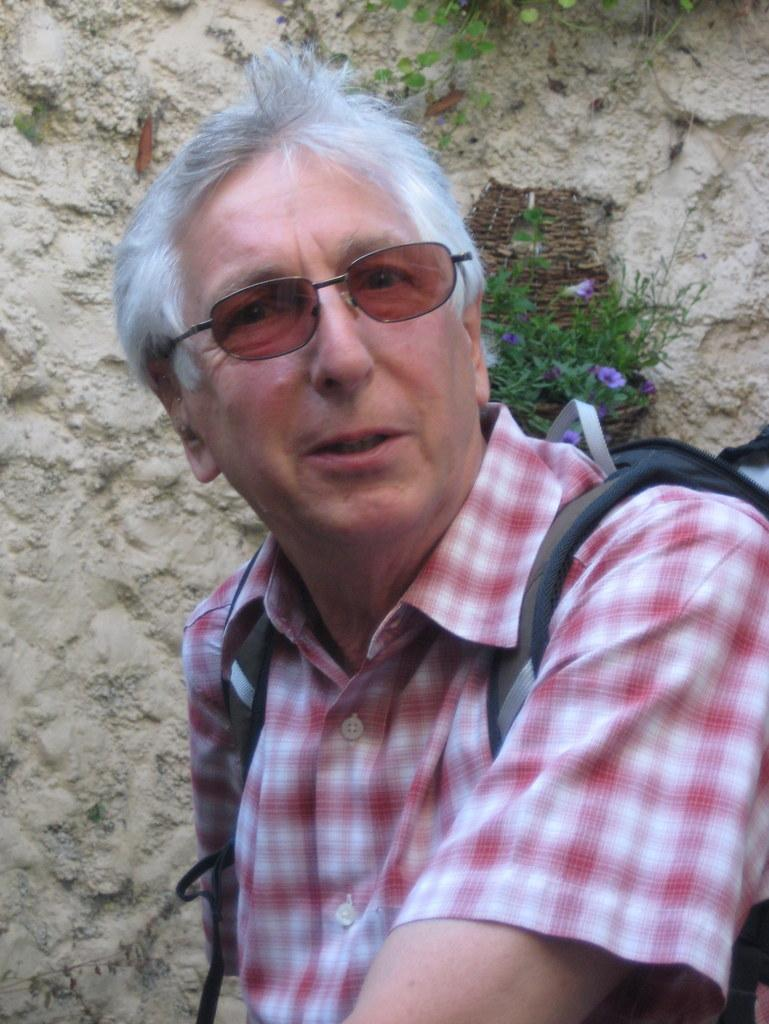Who is present in the image? There is a man in the image. What is the man wearing on his face? The man is wearing goggles. What type of clothing is the man wearing on his upper body? The man is wearing a shirt. What is the man carrying in the image? The man is carrying a bag. Where is the man standing in relation to the wall? The man is standing near a wall. What type of vegetation can be seen near the wall? There are flowers on a plant near the wall. What type of cream is being offered to the man in the image? There is no cream being offered to the man in the image. 